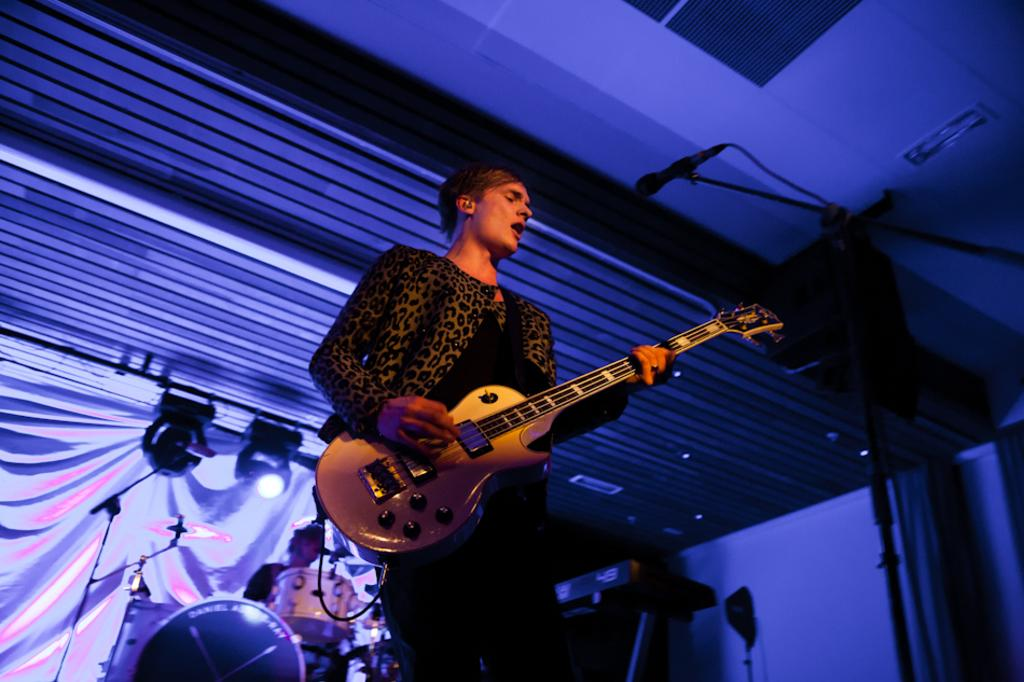What is the man in the image holding? The man in the image is holding a guitar. What is the other man in the image doing? The other man in the image is playing a drum set. Where is the cushion for the kitty in the image? There is no cushion or kitty present in the image. 